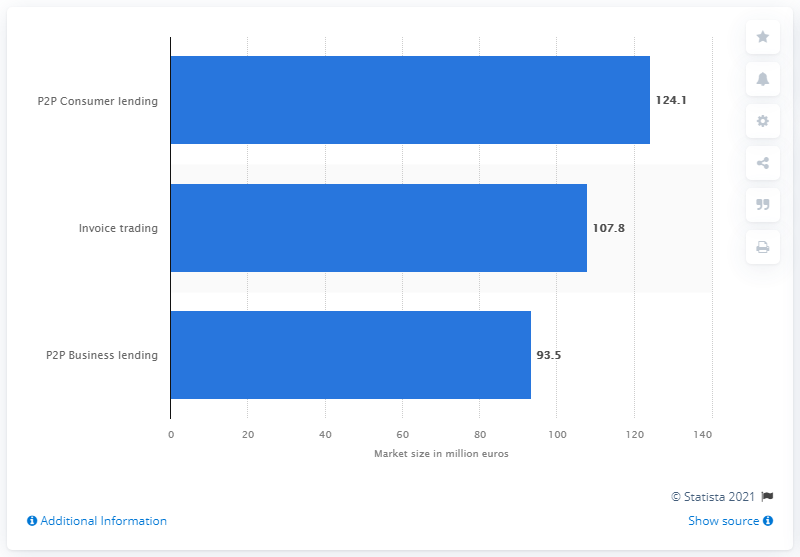Mention a couple of crucial points in this snapshot. In 2018, the market value of peer-to-peer business lending in Spain was approximately 93.5. 